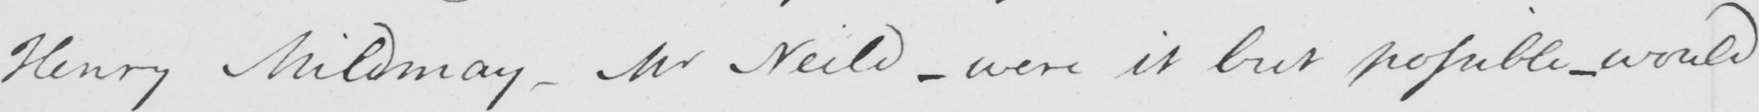What does this handwritten line say? Henry Mildmay  _  Mr Neild  _  were it but possible  _  would 